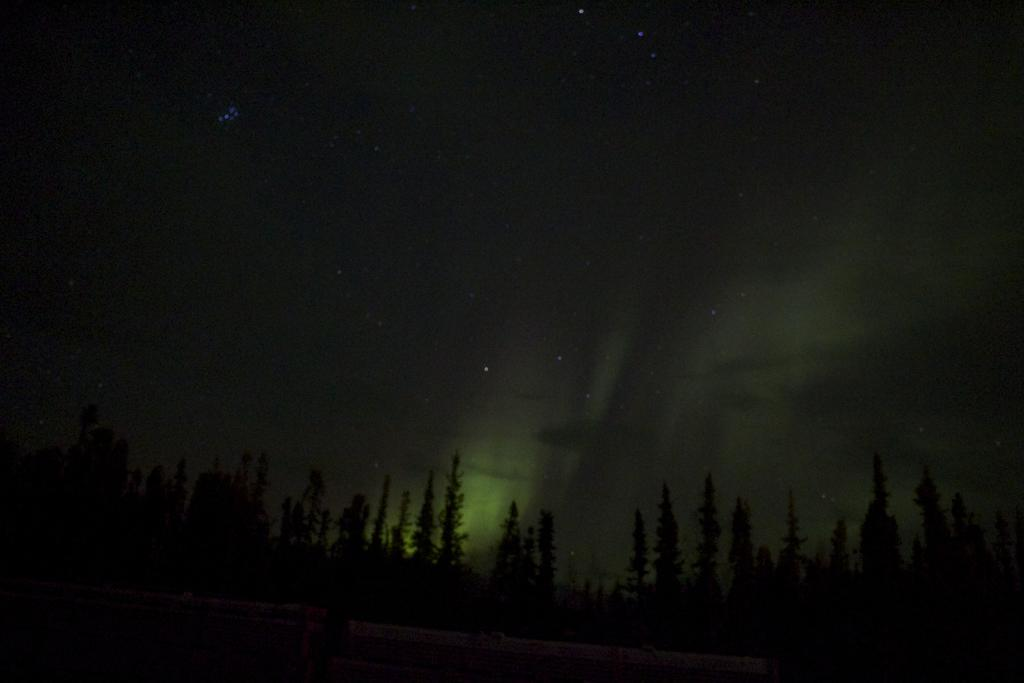What type of vegetation can be seen in the image? There is a group of trees in the image. What is the composition of the group in the image? The group consists of trees. What part of the natural environment is visible in the image? The sky is visible in the image. What celestial objects can be seen in the sky? There are stars in the sky. Who is the owner of the woman in the image? There is no woman present in the image, so it is not possible to determine the owner of a woman. 